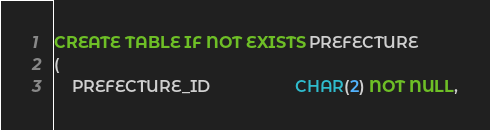Convert code to text. <code><loc_0><loc_0><loc_500><loc_500><_SQL_>CREATE TABLE IF NOT EXISTS PREFECTURE
(
    PREFECTURE_ID                   CHAR(2) NOT NULL,</code> 